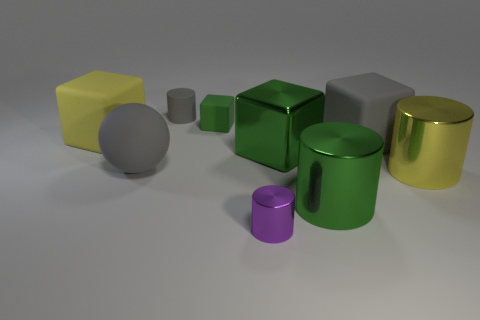Is the number of yellow cylinders less than the number of large metal objects?
Ensure brevity in your answer.  Yes. There is a big green metal thing that is in front of the metal cube; does it have the same shape as the large green metallic thing behind the yellow metal cylinder?
Offer a terse response. No. What is the color of the rubber ball?
Your response must be concise. Gray. How many rubber things are big cyan balls or large spheres?
Offer a very short reply. 1. The matte thing that is the same shape as the small purple shiny object is what color?
Your answer should be very brief. Gray. Are any large blocks visible?
Keep it short and to the point. Yes. Do the large yellow thing that is to the left of the small gray cylinder and the small thing that is in front of the large gray matte ball have the same material?
Keep it short and to the point. No. There is a small matte object that is the same color as the large matte ball; what shape is it?
Offer a very short reply. Cylinder. How many objects are either large rubber objects in front of the big yellow rubber block or green metal objects behind the yellow shiny thing?
Offer a terse response. 3. There is a large cylinder that is in front of the yellow shiny cylinder; is its color the same as the cylinder behind the big shiny block?
Provide a succinct answer. No. 